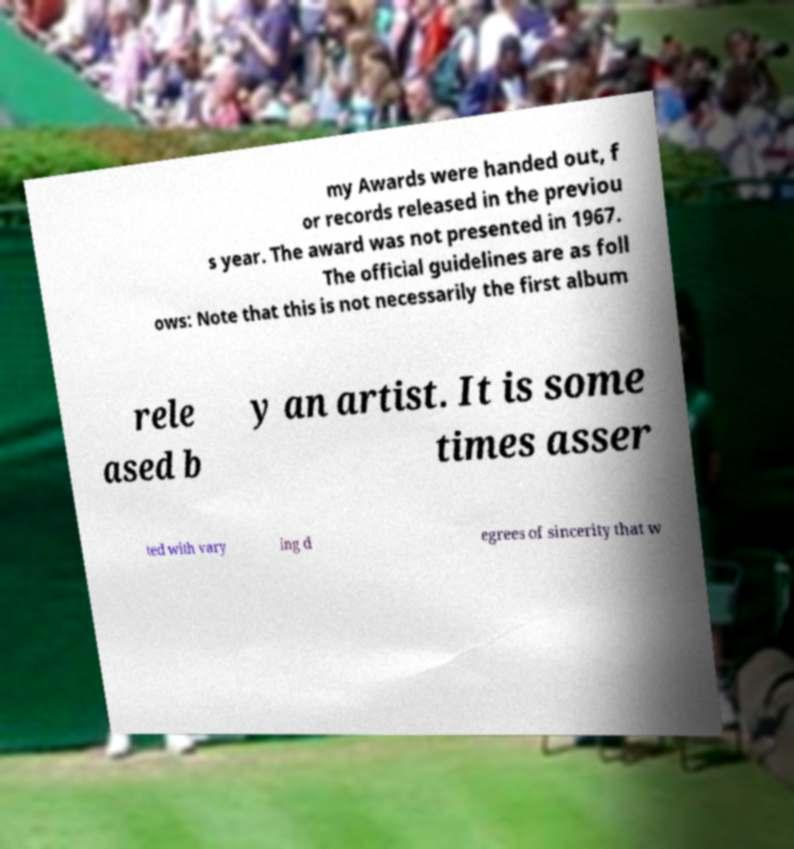I need the written content from this picture converted into text. Can you do that? my Awards were handed out, f or records released in the previou s year. The award was not presented in 1967. The official guidelines are as foll ows: Note that this is not necessarily the first album rele ased b y an artist. It is some times asser ted with vary ing d egrees of sincerity that w 